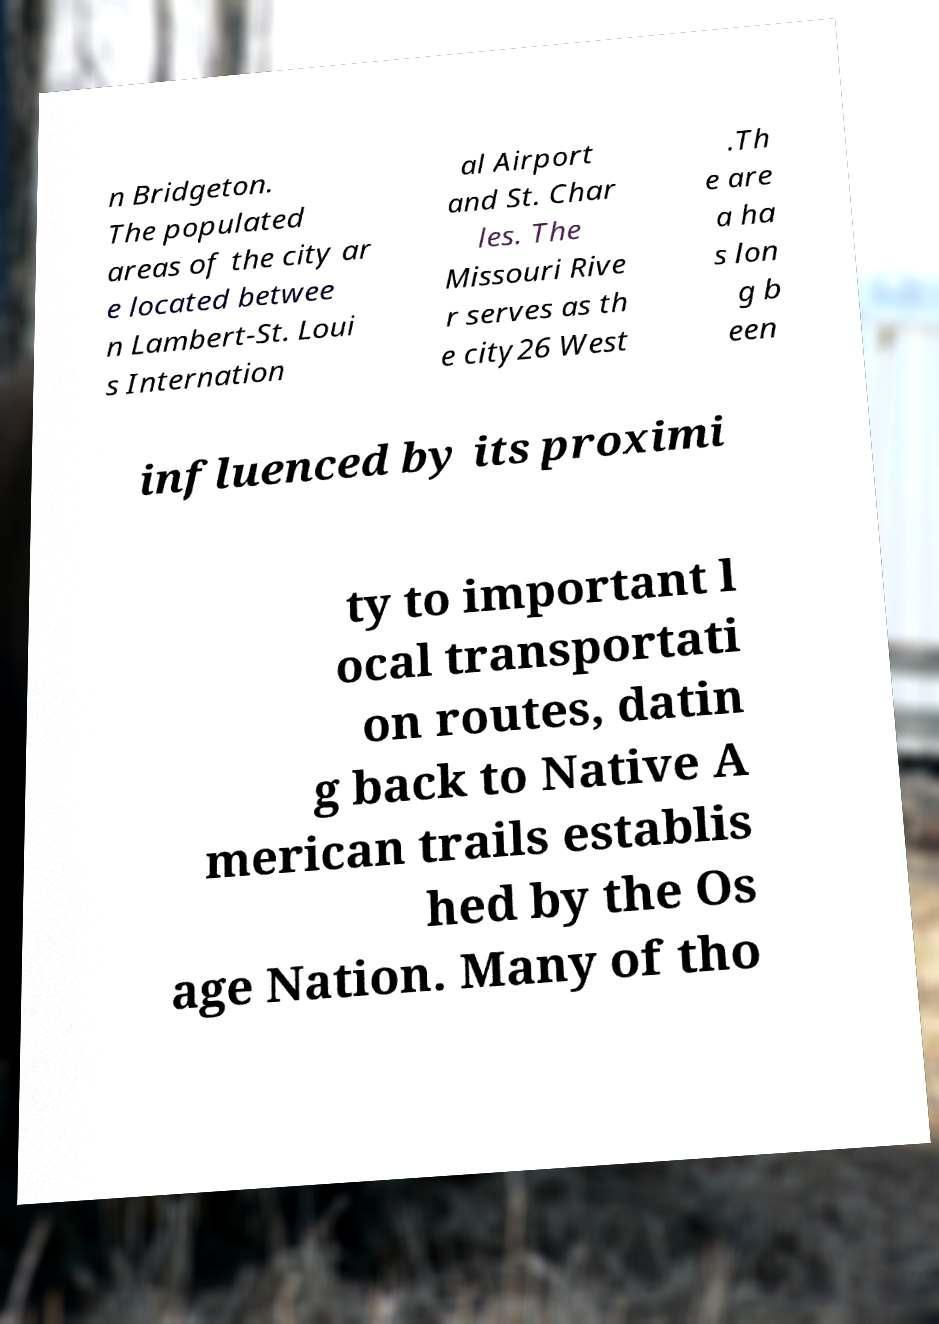What messages or text are displayed in this image? I need them in a readable, typed format. n Bridgeton. The populated areas of the city ar e located betwee n Lambert-St. Loui s Internation al Airport and St. Char les. The Missouri Rive r serves as th e city26 West .Th e are a ha s lon g b een influenced by its proximi ty to important l ocal transportati on routes, datin g back to Native A merican trails establis hed by the Os age Nation. Many of tho 